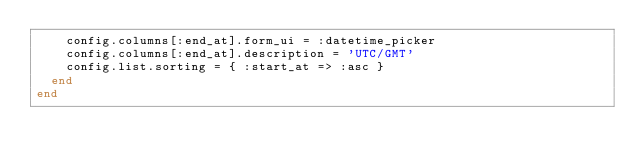<code> <loc_0><loc_0><loc_500><loc_500><_Ruby_>    config.columns[:end_at].form_ui = :datetime_picker
    config.columns[:end_at].description = 'UTC/GMT'
    config.list.sorting = { :start_at => :asc }
  end
end</code> 